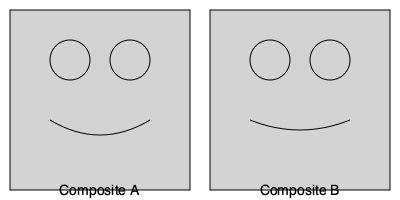Given two composite sketches of a person, what key facial feature shows the most significant difference between Composite A and Composite B? To answer this question, we need to analyze and compare the facial features in both composite sketches:

1. Eyes: Both composites show similar eye placement and size.
2. Nose: The nose is not prominently featured in either sketch.
3. Mouth/Smile: This is where we see the most significant difference.

Let's examine the mouth/smile in each composite:

Composite A:
- The smile curve is represented by a U-shaped line.
- The corners of the mouth are slightly upturned.
- The overall expression appears more neutral or slightly happy.

Composite B:
- The smile curve is represented by a shallower, broader curve.
- The corners of the mouth are more significantly upturned.
- The overall expression appears happier or more cheerful.

The difference in the mouth shape and expression is the most noticeable variation between the two composites. This feature could be crucial in identifying the person and potentially linking them to your father's true identity.
Answer: Mouth/smile shape 